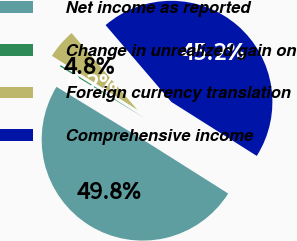Convert chart. <chart><loc_0><loc_0><loc_500><loc_500><pie_chart><fcel>Net income as reported<fcel>Change in unrealized gain on<fcel>Foreign currency translation<fcel>Comprehensive income<nl><fcel>49.76%<fcel>0.24%<fcel>4.76%<fcel>45.24%<nl></chart> 